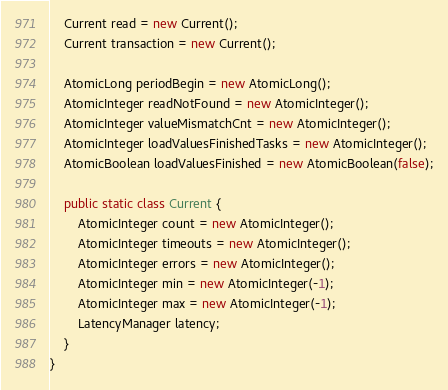Convert code to text. <code><loc_0><loc_0><loc_500><loc_500><_Java_>	Current read = new Current();
	Current transaction = new Current();
	
	AtomicLong periodBegin = new AtomicLong();	
	AtomicInteger readNotFound = new AtomicInteger();
	AtomicInteger valueMismatchCnt = new AtomicInteger();
	AtomicInteger loadValuesFinishedTasks = new AtomicInteger();
	AtomicBoolean loadValuesFinished = new AtomicBoolean(false);

	public static class Current {
		AtomicInteger count = new AtomicInteger();
		AtomicInteger timeouts = new AtomicInteger();
		AtomicInteger errors = new AtomicInteger();
		AtomicInteger min = new AtomicInteger(-1);
		AtomicInteger max = new AtomicInteger(-1);
		LatencyManager latency;
	}	
}
</code> 